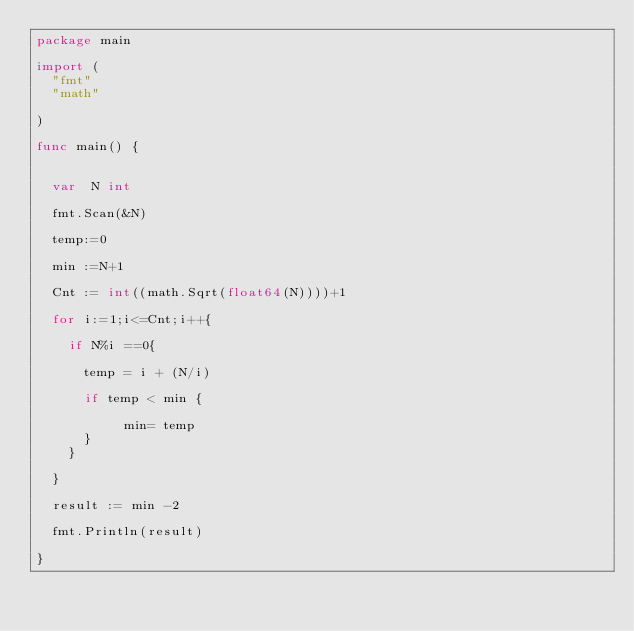<code> <loc_0><loc_0><loc_500><loc_500><_Go_>package main

import (
	"fmt"
	"math"

)

func main() {

	
	var  N int

	fmt.Scan(&N)

	temp:=0

	min :=N+1

	Cnt := int((math.Sqrt(float64(N))))+1

	for i:=1;i<=Cnt;i++{

		if N%i ==0{

			temp = i + (N/i)

			if temp < min {

			     min= temp
			}
		}

	}

	result := min -2

	fmt.Println(result)

}
</code> 